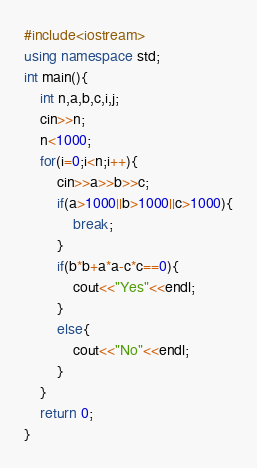Convert code to text. <code><loc_0><loc_0><loc_500><loc_500><_C++_>#include<iostream>
using namespace std;
int main(){
    int n,a,b,c,i,j;
    cin>>n;
    n<1000;
    for(i=0;i<n;i++){
        cin>>a>>b>>c;
        if(a>1000||b>1000||c>1000){
            break;
        }
        if(b*b+a*a-c*c==0){
            cout<<"Yes"<<endl;
        }
        else{
            cout<<"No"<<endl;
        }
    }
    return 0;
}</code> 